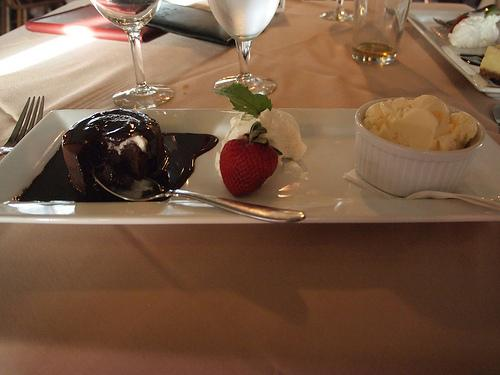Explain the placement of the fork in relation to the main dessert on the platter. The fork is placed on the side of the chocolate lava cake, ready for use. Choose one item from the selection of desserts and explain its appearance using descriptive language. The chocolate lava cake has a luscious, mouth-watering appearance with warm chocolate sauce oozing from the inside, inviting one to have a taste. What is the most prominent color of the tablecloth in the image? The tablecloth is primarily beige. What type of ice cream is served in the small white container and how does it relate to the main dessert? Vanilla ice cream is served in the small white container, presented as a complement to the chocolate lava cake. Describe the setting of this image in terms of a potential event. The image seems to be set at an upscale dining event or gathering, with an assortment of desserts and beverages elegantly presented on a table. Identify the objects placed on the table besides the desserts and beverages. There is a red tablet, a black case for the check, and a napkin on the table. In a short sentence, please describe the chocolate dessert's presentation. The chocolate lava cake is served with a ripe strawberry, whipped cream, and a mint leaf garnish. Identify the main dessert featured on the white platter in the image. The main dessert featured is a chocolate lava cake with a ripe strawberry and whipped cream with a mint leaf. Describe the visual relation between the whipped cream, strawberry, and the chocolate lava cake. The whipped cream is topped with a green leaf garnish and placed beside the chocolate lava cake, with a ripe red strawberry artistically positioned on the cake. Can you tell me what types of glasses are on the table? There are water, wine, and empty glasses on the table. 